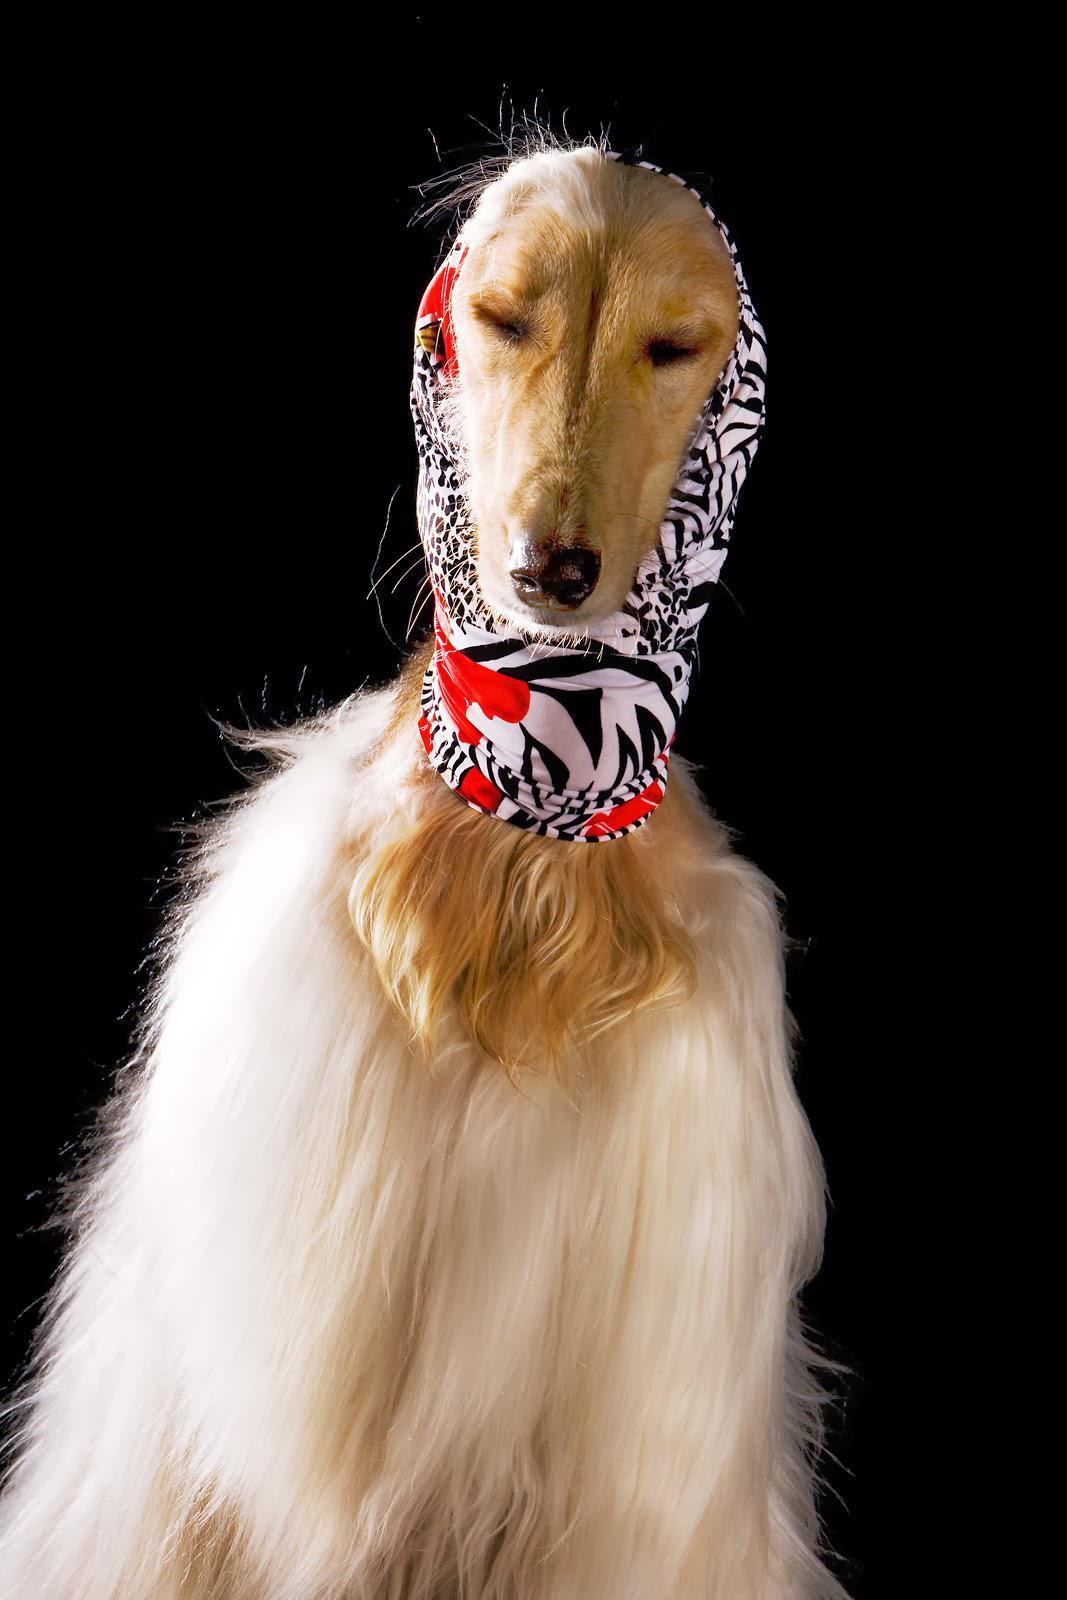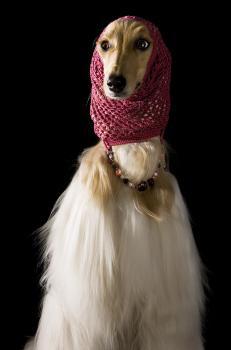The first image is the image on the left, the second image is the image on the right. Considering the images on both sides, is "Each image shows an afghan hound wearing a wrap that covers its neck, ears and the top of its head." valid? Answer yes or no. Yes. The first image is the image on the left, the second image is the image on the right. Given the left and right images, does the statement "Both images feature a dog wearing a head scarf." hold true? Answer yes or no. Yes. 